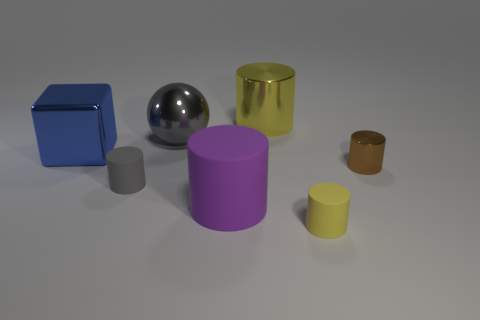Subtract all brown cylinders. How many cylinders are left? 4 Add 2 big blue things. How many objects exist? 9 Subtract all yellow cylinders. How many cylinders are left? 3 Subtract all green cubes. How many yellow cylinders are left? 2 Subtract all blocks. How many objects are left? 6 Subtract 2 cylinders. How many cylinders are left? 3 Subtract 0 red cylinders. How many objects are left? 7 Subtract all cyan cubes. Subtract all yellow cylinders. How many cubes are left? 1 Subtract all metal balls. Subtract all big purple spheres. How many objects are left? 6 Add 7 big yellow metallic cylinders. How many big yellow metallic cylinders are left? 8 